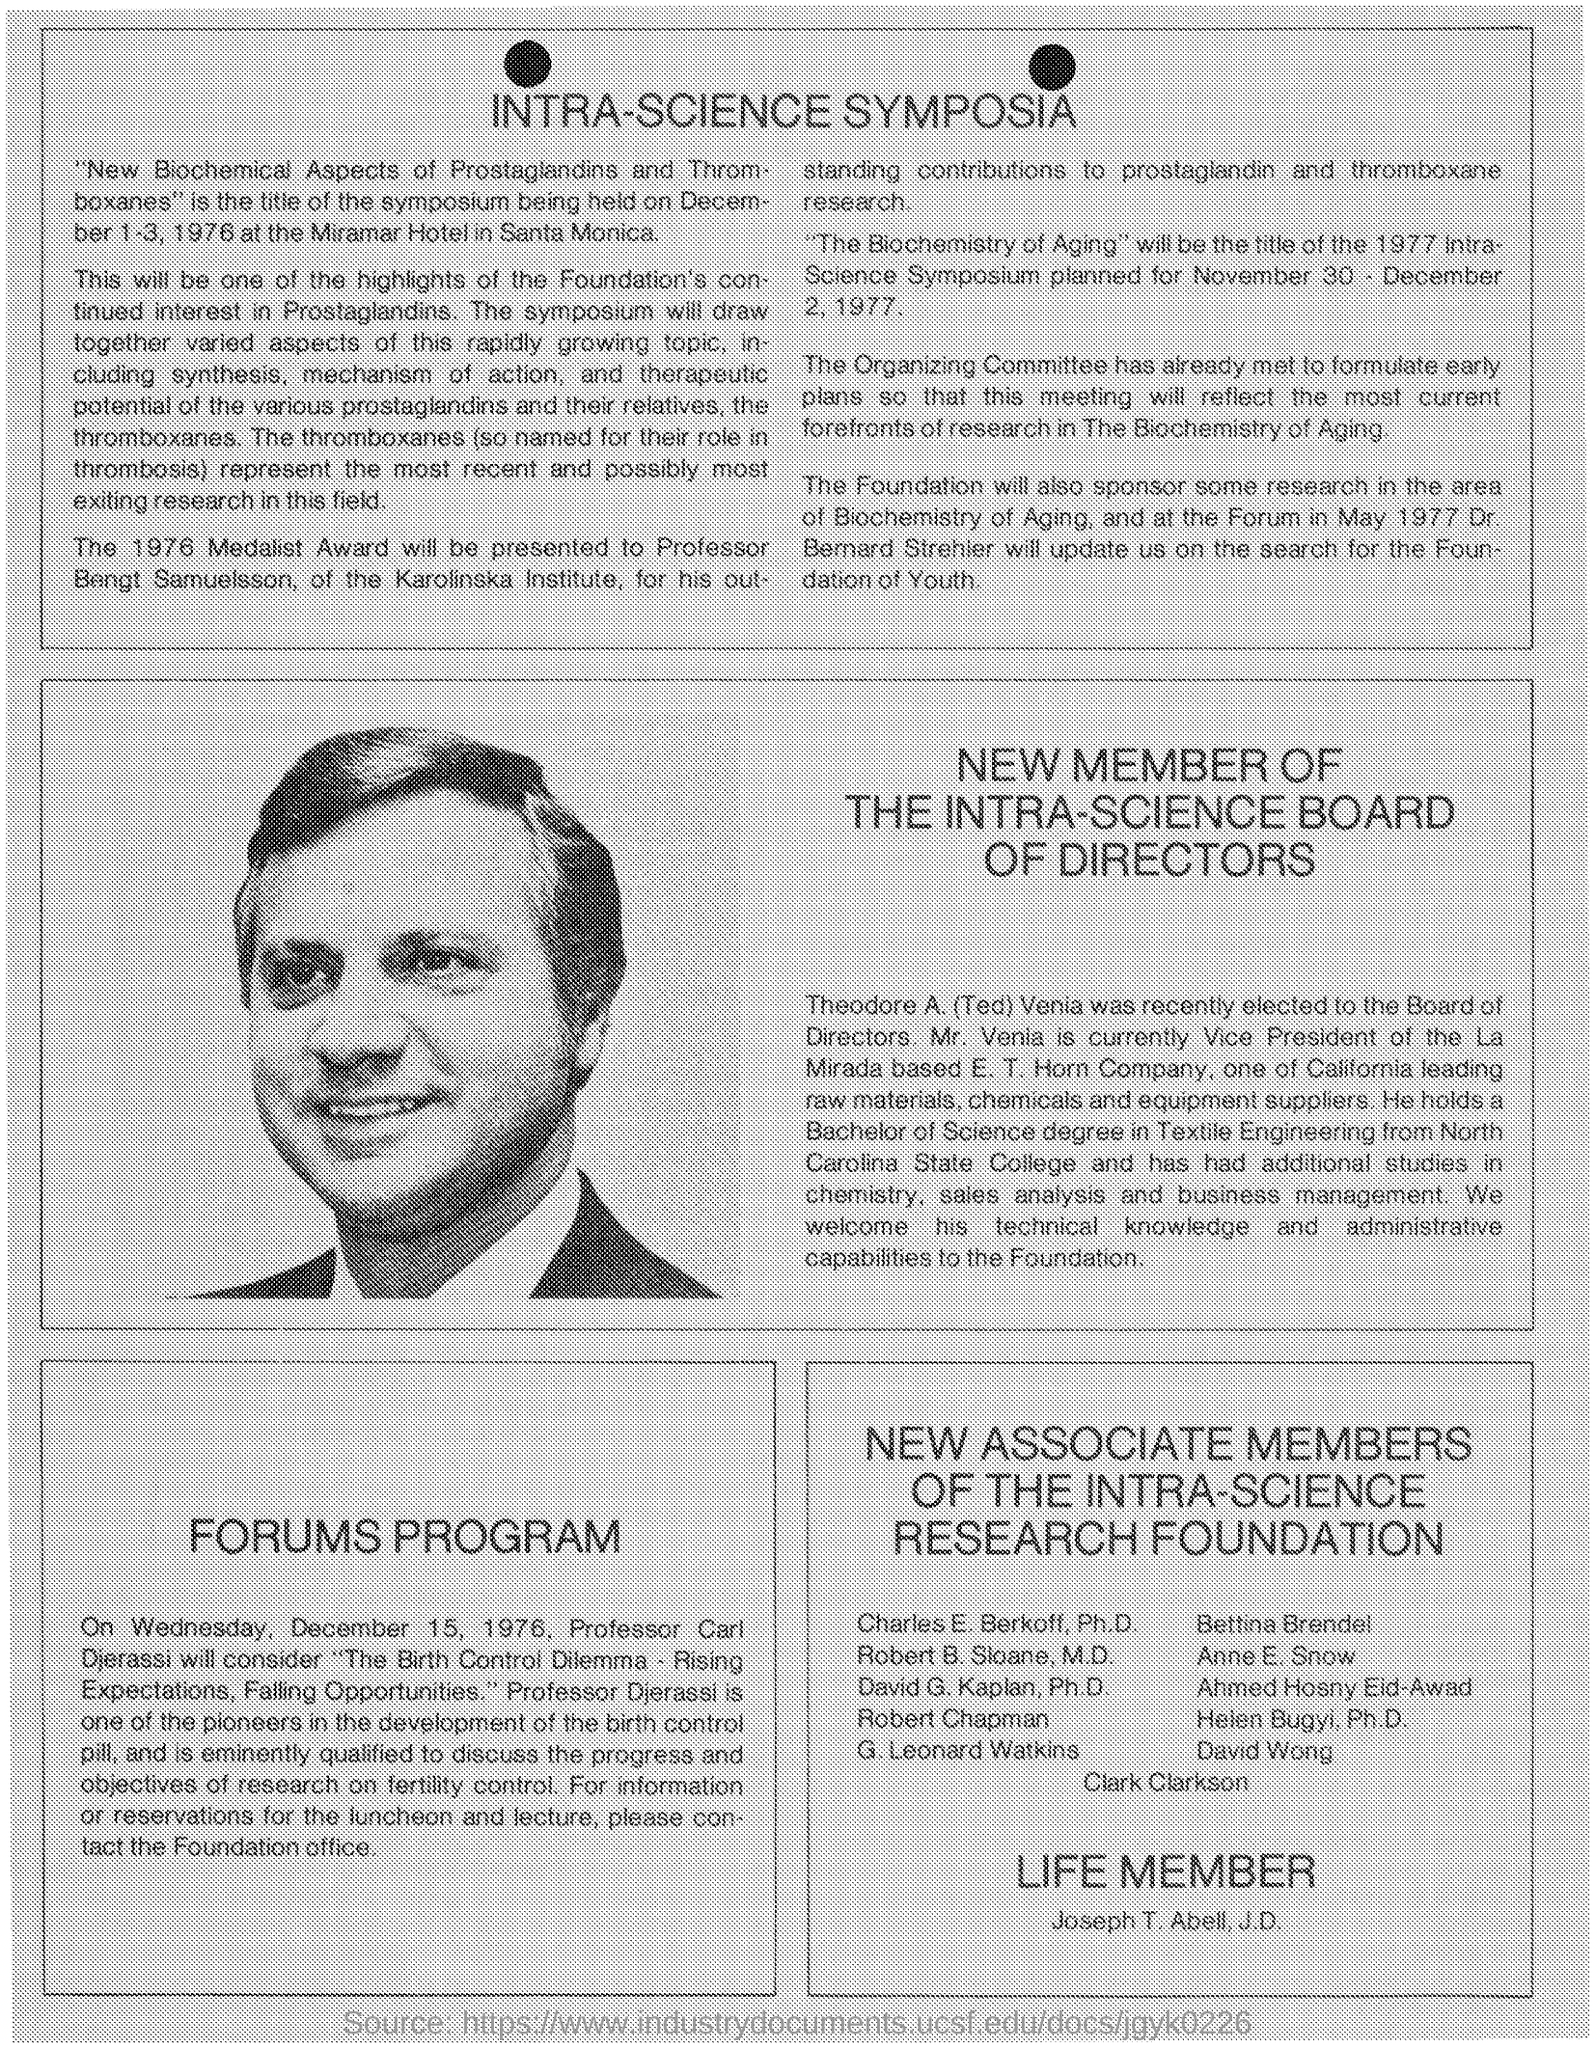Draw attention to some important aspects in this diagram. Bengt Samuelsson holds the designation of "Professor. The recipient of the "1976 Medalist Award" was Professor Bengt Samuelsson. The symposium on the topic "New Biochemical Aspects of Prostaglandins and Thromboxanes" will be held at the Miramar Hotel in Santa Monica. The symposium on the title 'New Biochemical Aspects of Prostaglandins and Thromboxanes' was held from DECEMBER 1-3, 1976. As of my knowledge cutoff date, Mr. Venia was serving as the vice president of La Mirada. 